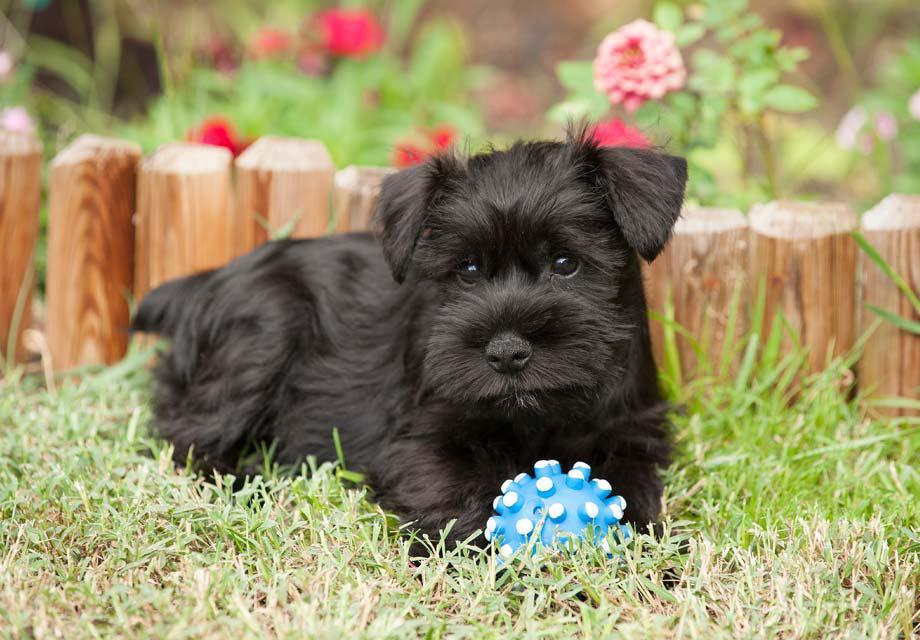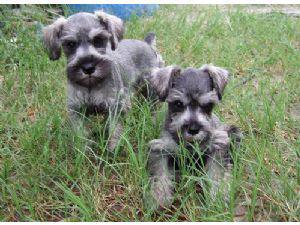The first image is the image on the left, the second image is the image on the right. Given the left and right images, does the statement "There are three dogs" hold true? Answer yes or no. Yes. The first image is the image on the left, the second image is the image on the right. Analyze the images presented: Is the assertion "Two schnauzers pose in the grass in one image." valid? Answer yes or no. Yes. 